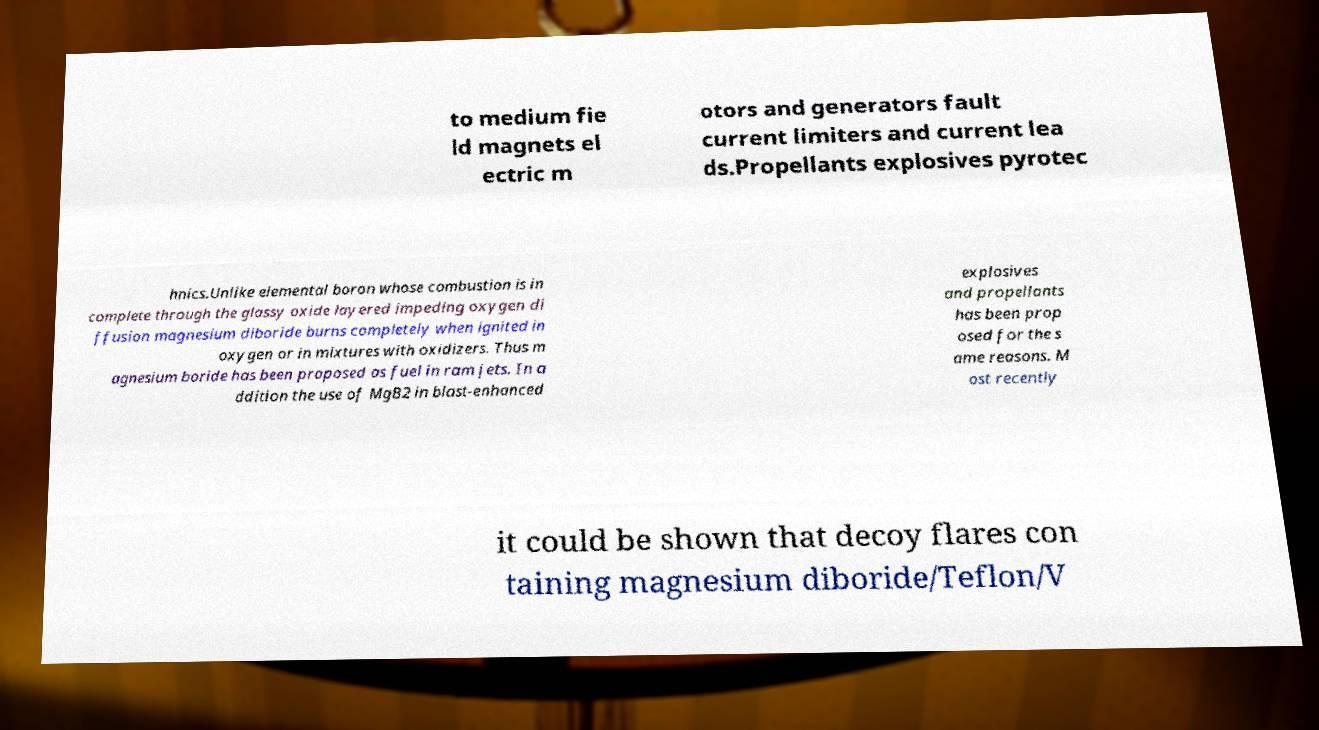Please identify and transcribe the text found in this image. to medium fie ld magnets el ectric m otors and generators fault current limiters and current lea ds.Propellants explosives pyrotec hnics.Unlike elemental boron whose combustion is in complete through the glassy oxide layered impeding oxygen di ffusion magnesium diboride burns completely when ignited in oxygen or in mixtures with oxidizers. Thus m agnesium boride has been proposed as fuel in ram jets. In a ddition the use of MgB2 in blast-enhanced explosives and propellants has been prop osed for the s ame reasons. M ost recently it could be shown that decoy flares con taining magnesium diboride/Teflon/V 